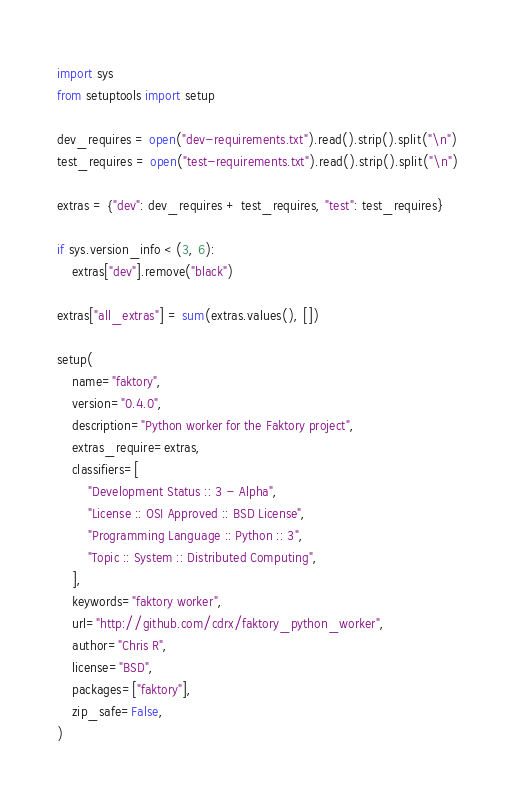<code> <loc_0><loc_0><loc_500><loc_500><_Python_>import sys
from setuptools import setup

dev_requires = open("dev-requirements.txt").read().strip().split("\n")
test_requires = open("test-requirements.txt").read().strip().split("\n")

extras = {"dev": dev_requires + test_requires, "test": test_requires}

if sys.version_info < (3, 6):
    extras["dev"].remove("black")

extras["all_extras"] = sum(extras.values(), [])

setup(
    name="faktory",
    version="0.4.0",
    description="Python worker for the Faktory project",
    extras_require=extras,
    classifiers=[
        "Development Status :: 3 - Alpha",
        "License :: OSI Approved :: BSD License",
        "Programming Language :: Python :: 3",
        "Topic :: System :: Distributed Computing",
    ],
    keywords="faktory worker",
    url="http://github.com/cdrx/faktory_python_worker",
    author="Chris R",
    license="BSD",
    packages=["faktory"],
    zip_safe=False,
)
</code> 